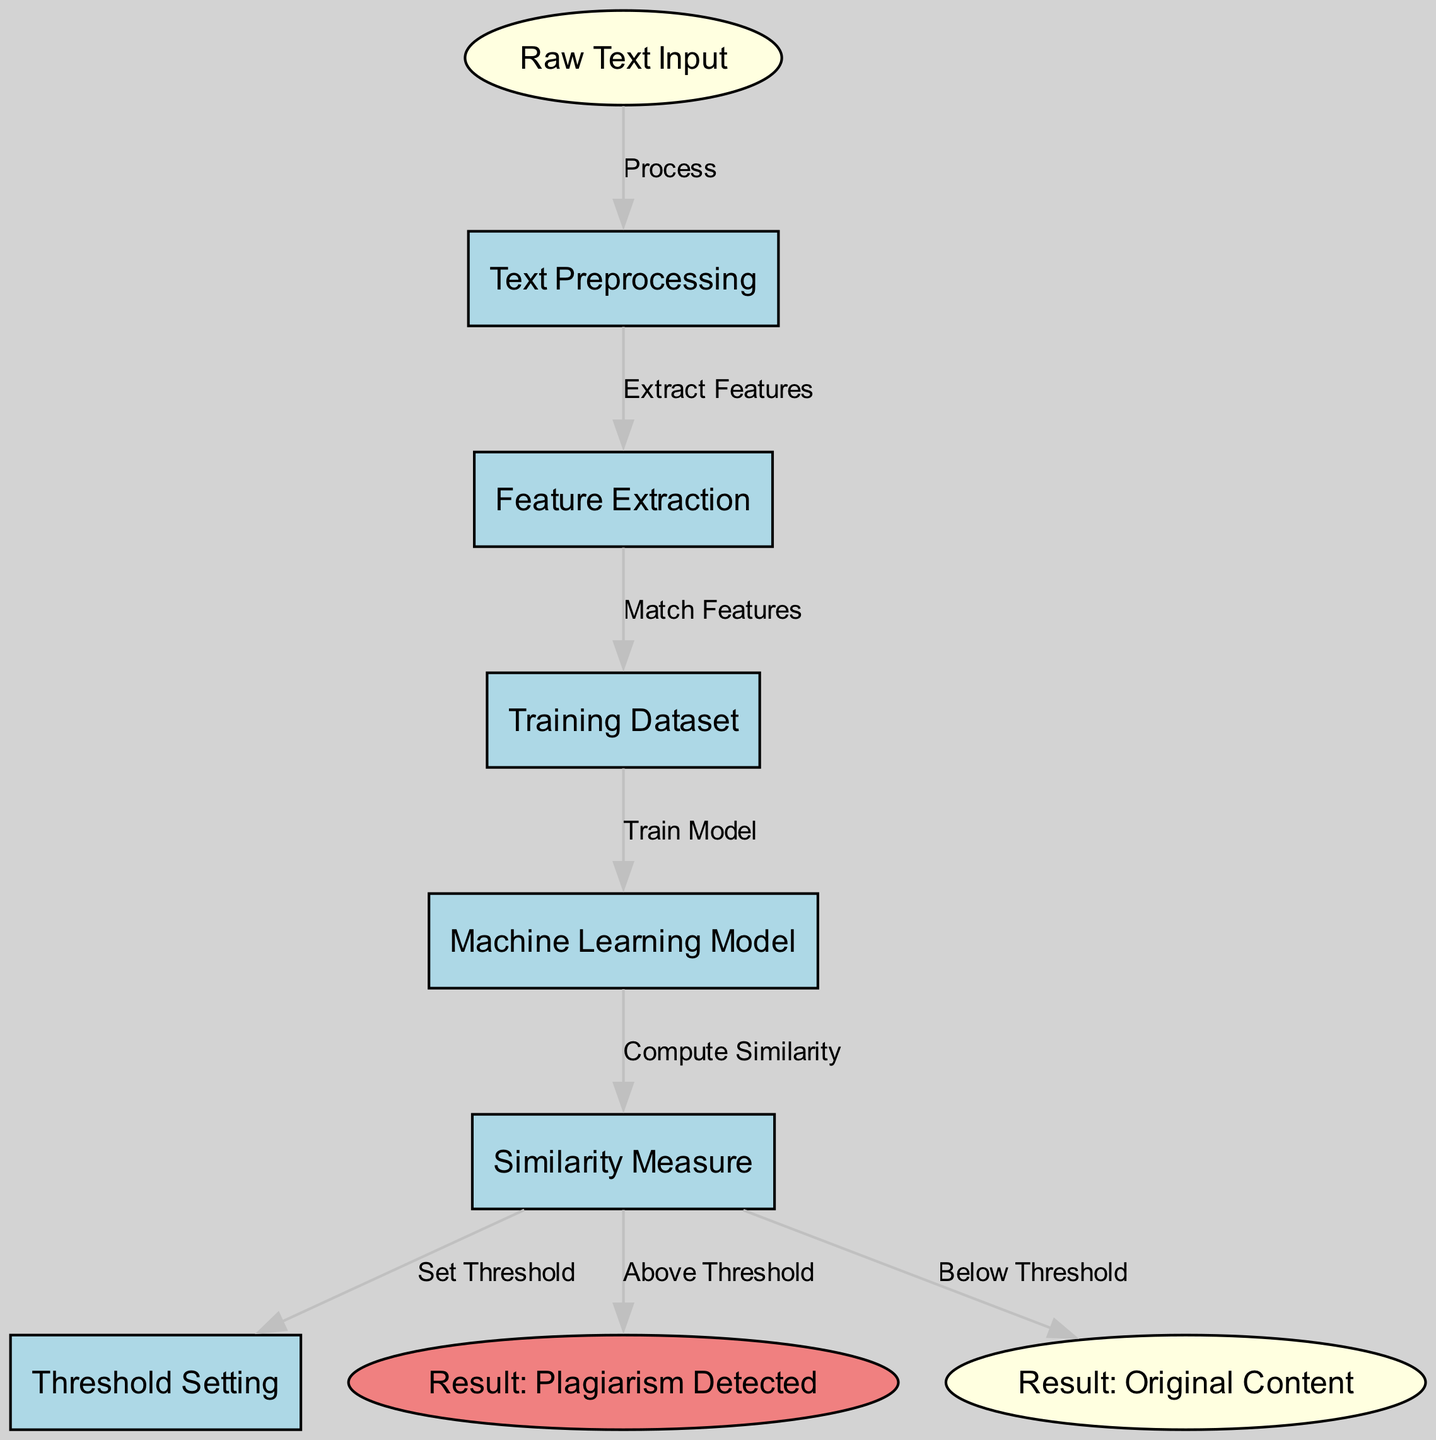What is the first step in the plagiarism detection process? The first node labeled "Raw Text Input" represents the initial stage of the plagiarism detection process.
Answer: Raw Text Input How many nodes are depicted in the diagram? The diagram contains a total of nine nodes, each representing a distinct step in the process.
Answer: Nine What is the relationship between "Text Preprocessing" and "Feature Extraction"? The edge connecting the "Text Preprocessing" node and the "Feature Extraction" node is labeled "Extract Features," indicating that features are extracted during this phase after preprocessing.
Answer: Extract Features What happens after "Compute Similarity"? From the "Compute Similarity" node, there are three potential outcomes; a threshold is set, and based on whether the result is above or below that threshold, the output can lead to either "Plagiarism Detected" or "Original Content."
Answer: Plagiarism Detected or Original Content Which node represents the resultant state when content is original? The "Result: Original Content" node represents the outcome when the content does not match the existing data above the threshold.
Answer: Result: Original Content What is the function of the "Threshold Setting" node? The "Threshold Setting" node establishes a boundary that determines whether the computed similarity qualifies as plagiarism or original content, relying on the outcome from the similarity measure.
Answer: Set Threshold What action follows the "Training Dataset" node? The "Training Dataset" leads directly to the "Machine Learning Model," where the previously matched features are used to train the model in the plagiarism detection process.
Answer: Train Model After setting the threshold, what output can occur? After the threshold is set, there are two potential outputs based on the similarity measure, which leads to either "Plagiarism Detected" or "Original Content."
Answer: Plagiarism Detected or Original Content 